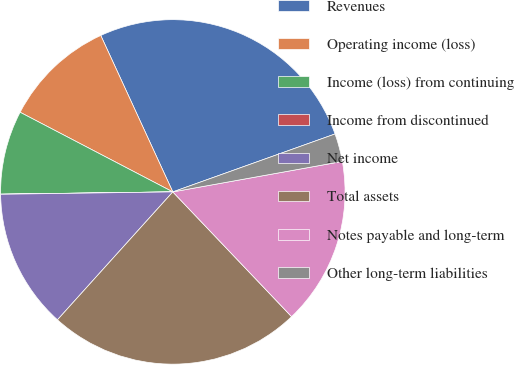<chart> <loc_0><loc_0><loc_500><loc_500><pie_chart><fcel>Revenues<fcel>Operating income (loss)<fcel>Income (loss) from continuing<fcel>Income from discontinued<fcel>Net income<fcel>Total assets<fcel>Notes payable and long-term<fcel>Other long-term liabilities<nl><fcel>26.41%<fcel>10.48%<fcel>7.86%<fcel>0.01%<fcel>13.1%<fcel>23.79%<fcel>15.72%<fcel>2.63%<nl></chart> 